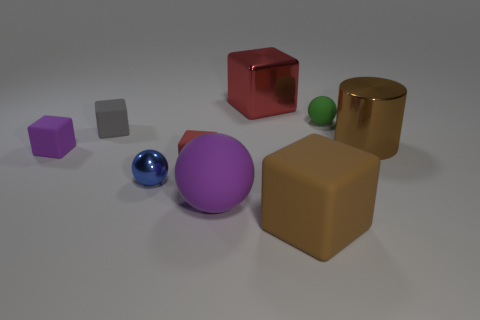Add 1 tiny gray cubes. How many objects exist? 10 Subtract all tiny blocks. How many blocks are left? 2 Subtract 3 cubes. How many cubes are left? 2 Subtract all cylinders. How many objects are left? 8 Subtract all cyan cubes. Subtract all red cylinders. How many cubes are left? 5 Subtract all purple cylinders. How many blue spheres are left? 1 Subtract all big matte balls. Subtract all big red cylinders. How many objects are left? 8 Add 6 big cubes. How many big cubes are left? 8 Add 5 metallic cylinders. How many metallic cylinders exist? 6 Subtract all brown blocks. How many blocks are left? 4 